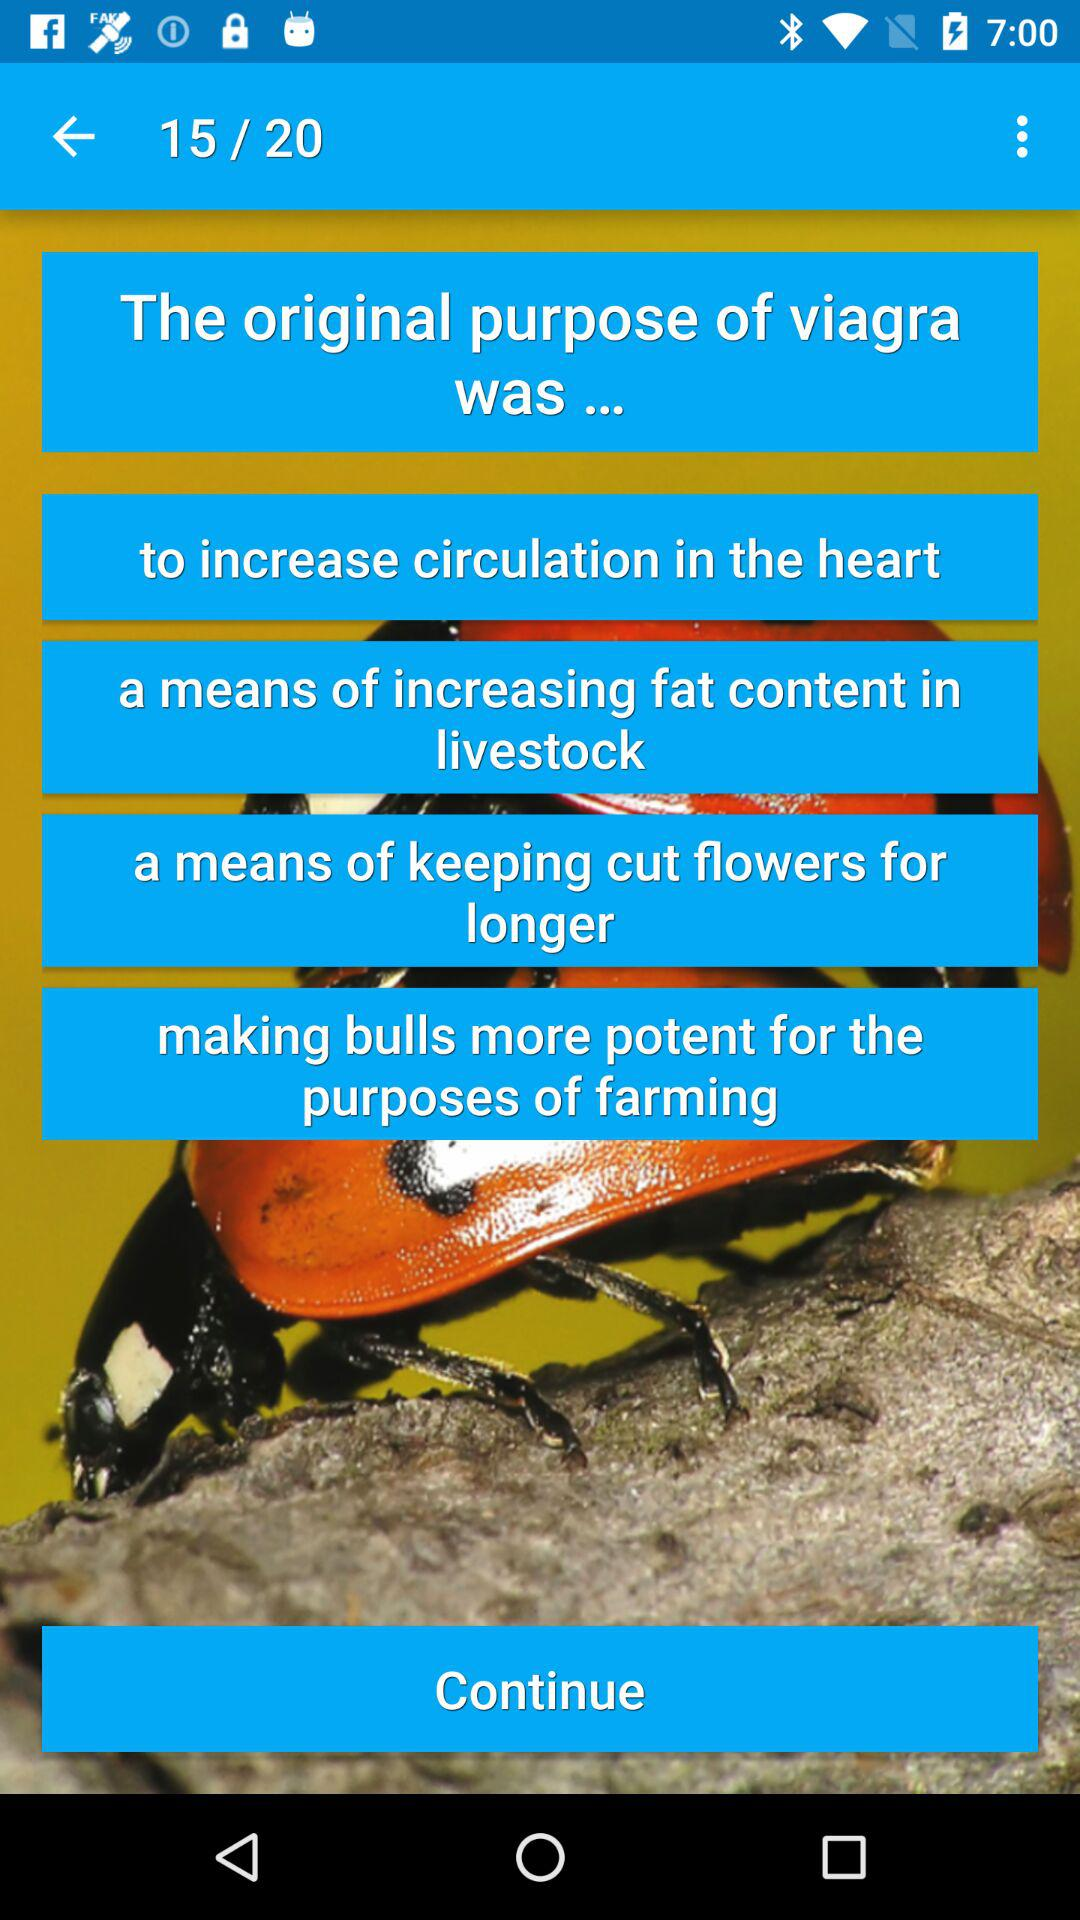How many pages in total are there? There are 20 pages in total. 